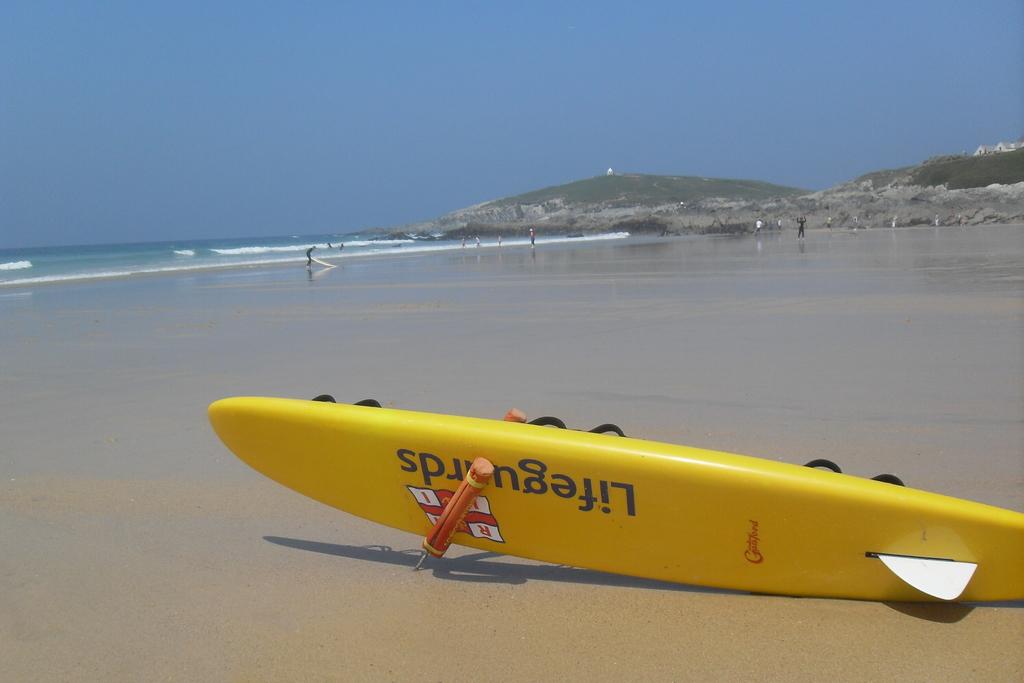What does the black letters say?
Ensure brevity in your answer.  Lifeguards. What in on the surfboard?
Offer a very short reply. Lifeguards. 